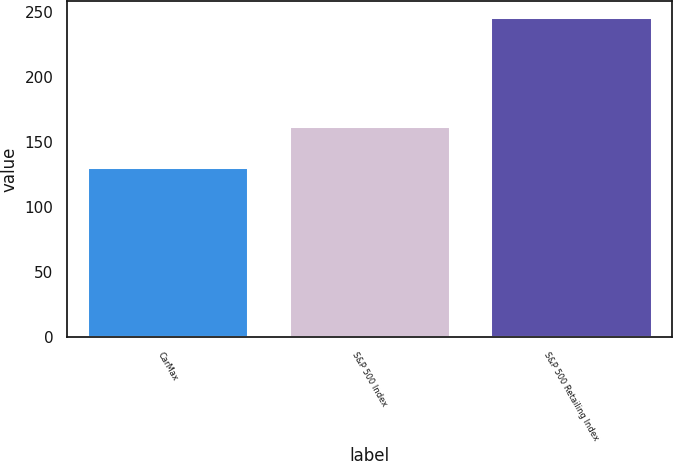<chart> <loc_0><loc_0><loc_500><loc_500><bar_chart><fcel>CarMax<fcel>S&P 500 Index<fcel>S&P 500 Retailing Index<nl><fcel>130.79<fcel>162.03<fcel>246.06<nl></chart> 